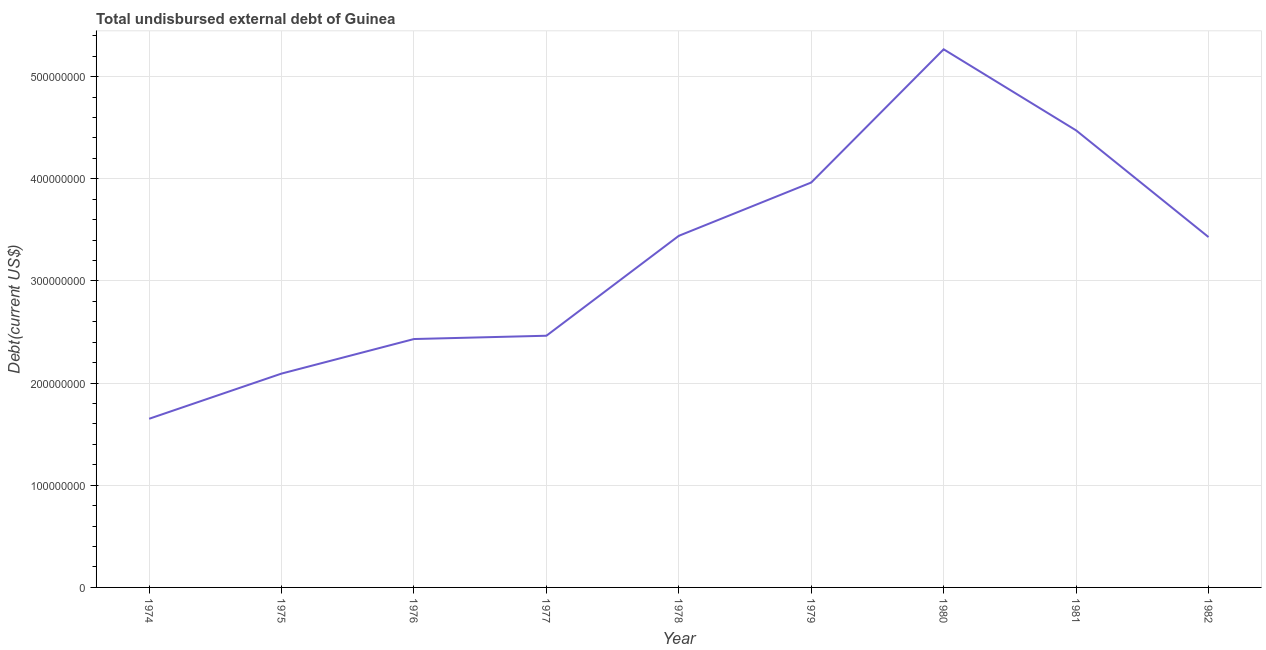What is the total debt in 1976?
Your answer should be compact. 2.43e+08. Across all years, what is the maximum total debt?
Keep it short and to the point. 5.27e+08. Across all years, what is the minimum total debt?
Your response must be concise. 1.65e+08. In which year was the total debt minimum?
Offer a terse response. 1974. What is the sum of the total debt?
Your response must be concise. 2.92e+09. What is the difference between the total debt in 1976 and 1982?
Keep it short and to the point. -9.98e+07. What is the average total debt per year?
Provide a succinct answer. 3.25e+08. What is the median total debt?
Provide a short and direct response. 3.43e+08. In how many years, is the total debt greater than 220000000 US$?
Offer a terse response. 7. What is the ratio of the total debt in 1975 to that in 1980?
Your answer should be very brief. 0.4. What is the difference between the highest and the second highest total debt?
Provide a short and direct response. 7.94e+07. Is the sum of the total debt in 1980 and 1981 greater than the maximum total debt across all years?
Your answer should be compact. Yes. What is the difference between the highest and the lowest total debt?
Make the answer very short. 3.62e+08. Does the total debt monotonically increase over the years?
Offer a very short reply. No. How many lines are there?
Provide a succinct answer. 1. How many years are there in the graph?
Your response must be concise. 9. What is the difference between two consecutive major ticks on the Y-axis?
Provide a short and direct response. 1.00e+08. Does the graph contain any zero values?
Ensure brevity in your answer.  No. What is the title of the graph?
Offer a terse response. Total undisbursed external debt of Guinea. What is the label or title of the X-axis?
Give a very brief answer. Year. What is the label or title of the Y-axis?
Provide a succinct answer. Debt(current US$). What is the Debt(current US$) of 1974?
Offer a terse response. 1.65e+08. What is the Debt(current US$) of 1975?
Give a very brief answer. 2.09e+08. What is the Debt(current US$) of 1976?
Provide a short and direct response. 2.43e+08. What is the Debt(current US$) of 1977?
Provide a succinct answer. 2.46e+08. What is the Debt(current US$) of 1978?
Make the answer very short. 3.44e+08. What is the Debt(current US$) of 1979?
Provide a short and direct response. 3.96e+08. What is the Debt(current US$) in 1980?
Keep it short and to the point. 5.27e+08. What is the Debt(current US$) of 1981?
Make the answer very short. 4.47e+08. What is the Debt(current US$) of 1982?
Your answer should be compact. 3.43e+08. What is the difference between the Debt(current US$) in 1974 and 1975?
Keep it short and to the point. -4.42e+07. What is the difference between the Debt(current US$) in 1974 and 1976?
Your answer should be very brief. -7.80e+07. What is the difference between the Debt(current US$) in 1974 and 1977?
Offer a terse response. -8.13e+07. What is the difference between the Debt(current US$) in 1974 and 1978?
Offer a terse response. -1.79e+08. What is the difference between the Debt(current US$) in 1974 and 1979?
Offer a terse response. -2.31e+08. What is the difference between the Debt(current US$) in 1974 and 1980?
Provide a short and direct response. -3.62e+08. What is the difference between the Debt(current US$) in 1974 and 1981?
Your response must be concise. -2.82e+08. What is the difference between the Debt(current US$) in 1974 and 1982?
Ensure brevity in your answer.  -1.78e+08. What is the difference between the Debt(current US$) in 1975 and 1976?
Provide a succinct answer. -3.38e+07. What is the difference between the Debt(current US$) in 1975 and 1977?
Make the answer very short. -3.70e+07. What is the difference between the Debt(current US$) in 1975 and 1978?
Your response must be concise. -1.35e+08. What is the difference between the Debt(current US$) in 1975 and 1979?
Your answer should be very brief. -1.87e+08. What is the difference between the Debt(current US$) in 1975 and 1980?
Keep it short and to the point. -3.17e+08. What is the difference between the Debt(current US$) in 1975 and 1981?
Offer a terse response. -2.38e+08. What is the difference between the Debt(current US$) in 1975 and 1982?
Offer a very short reply. -1.34e+08. What is the difference between the Debt(current US$) in 1976 and 1977?
Your answer should be very brief. -3.22e+06. What is the difference between the Debt(current US$) in 1976 and 1978?
Offer a terse response. -1.01e+08. What is the difference between the Debt(current US$) in 1976 and 1979?
Keep it short and to the point. -1.53e+08. What is the difference between the Debt(current US$) in 1976 and 1980?
Your response must be concise. -2.84e+08. What is the difference between the Debt(current US$) in 1976 and 1981?
Make the answer very short. -2.04e+08. What is the difference between the Debt(current US$) in 1976 and 1982?
Provide a succinct answer. -9.98e+07. What is the difference between the Debt(current US$) in 1977 and 1978?
Your answer should be compact. -9.78e+07. What is the difference between the Debt(current US$) in 1977 and 1979?
Provide a succinct answer. -1.50e+08. What is the difference between the Debt(current US$) in 1977 and 1980?
Your answer should be compact. -2.80e+08. What is the difference between the Debt(current US$) in 1977 and 1981?
Make the answer very short. -2.01e+08. What is the difference between the Debt(current US$) in 1977 and 1982?
Provide a succinct answer. -9.66e+07. What is the difference between the Debt(current US$) in 1978 and 1979?
Your answer should be very brief. -5.22e+07. What is the difference between the Debt(current US$) in 1978 and 1980?
Provide a short and direct response. -1.83e+08. What is the difference between the Debt(current US$) in 1978 and 1981?
Provide a succinct answer. -1.03e+08. What is the difference between the Debt(current US$) in 1978 and 1982?
Ensure brevity in your answer.  1.25e+06. What is the difference between the Debt(current US$) in 1979 and 1980?
Offer a very short reply. -1.30e+08. What is the difference between the Debt(current US$) in 1979 and 1981?
Your answer should be very brief. -5.10e+07. What is the difference between the Debt(current US$) in 1979 and 1982?
Provide a succinct answer. 5.34e+07. What is the difference between the Debt(current US$) in 1980 and 1981?
Your answer should be very brief. 7.94e+07. What is the difference between the Debt(current US$) in 1980 and 1982?
Provide a short and direct response. 1.84e+08. What is the difference between the Debt(current US$) in 1981 and 1982?
Your response must be concise. 1.04e+08. What is the ratio of the Debt(current US$) in 1974 to that in 1975?
Provide a succinct answer. 0.79. What is the ratio of the Debt(current US$) in 1974 to that in 1976?
Keep it short and to the point. 0.68. What is the ratio of the Debt(current US$) in 1974 to that in 1977?
Make the answer very short. 0.67. What is the ratio of the Debt(current US$) in 1974 to that in 1978?
Offer a terse response. 0.48. What is the ratio of the Debt(current US$) in 1974 to that in 1979?
Ensure brevity in your answer.  0.42. What is the ratio of the Debt(current US$) in 1974 to that in 1980?
Give a very brief answer. 0.31. What is the ratio of the Debt(current US$) in 1974 to that in 1981?
Keep it short and to the point. 0.37. What is the ratio of the Debt(current US$) in 1974 to that in 1982?
Keep it short and to the point. 0.48. What is the ratio of the Debt(current US$) in 1975 to that in 1976?
Keep it short and to the point. 0.86. What is the ratio of the Debt(current US$) in 1975 to that in 1977?
Make the answer very short. 0.85. What is the ratio of the Debt(current US$) in 1975 to that in 1978?
Provide a succinct answer. 0.61. What is the ratio of the Debt(current US$) in 1975 to that in 1979?
Provide a succinct answer. 0.53. What is the ratio of the Debt(current US$) in 1975 to that in 1980?
Your answer should be very brief. 0.4. What is the ratio of the Debt(current US$) in 1975 to that in 1981?
Your response must be concise. 0.47. What is the ratio of the Debt(current US$) in 1975 to that in 1982?
Give a very brief answer. 0.61. What is the ratio of the Debt(current US$) in 1976 to that in 1977?
Give a very brief answer. 0.99. What is the ratio of the Debt(current US$) in 1976 to that in 1978?
Provide a short and direct response. 0.71. What is the ratio of the Debt(current US$) in 1976 to that in 1979?
Provide a succinct answer. 0.61. What is the ratio of the Debt(current US$) in 1976 to that in 1980?
Make the answer very short. 0.46. What is the ratio of the Debt(current US$) in 1976 to that in 1981?
Your answer should be very brief. 0.54. What is the ratio of the Debt(current US$) in 1976 to that in 1982?
Make the answer very short. 0.71. What is the ratio of the Debt(current US$) in 1977 to that in 1978?
Ensure brevity in your answer.  0.72. What is the ratio of the Debt(current US$) in 1977 to that in 1979?
Keep it short and to the point. 0.62. What is the ratio of the Debt(current US$) in 1977 to that in 1980?
Offer a terse response. 0.47. What is the ratio of the Debt(current US$) in 1977 to that in 1981?
Provide a succinct answer. 0.55. What is the ratio of the Debt(current US$) in 1977 to that in 1982?
Offer a terse response. 0.72. What is the ratio of the Debt(current US$) in 1978 to that in 1979?
Keep it short and to the point. 0.87. What is the ratio of the Debt(current US$) in 1978 to that in 1980?
Provide a succinct answer. 0.65. What is the ratio of the Debt(current US$) in 1978 to that in 1981?
Your answer should be compact. 0.77. What is the ratio of the Debt(current US$) in 1978 to that in 1982?
Your answer should be very brief. 1. What is the ratio of the Debt(current US$) in 1979 to that in 1980?
Your answer should be compact. 0.75. What is the ratio of the Debt(current US$) in 1979 to that in 1981?
Provide a succinct answer. 0.89. What is the ratio of the Debt(current US$) in 1979 to that in 1982?
Your response must be concise. 1.16. What is the ratio of the Debt(current US$) in 1980 to that in 1981?
Keep it short and to the point. 1.18. What is the ratio of the Debt(current US$) in 1980 to that in 1982?
Offer a very short reply. 1.54. What is the ratio of the Debt(current US$) in 1981 to that in 1982?
Give a very brief answer. 1.3. 